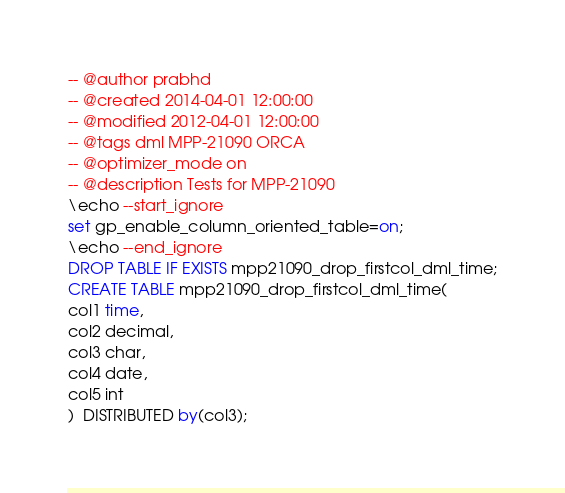<code> <loc_0><loc_0><loc_500><loc_500><_SQL_>-- @author prabhd 
-- @created 2014-04-01 12:00:00
-- @modified 2012-04-01 12:00:00
-- @tags dml MPP-21090 ORCA
-- @optimizer_mode on	
-- @description Tests for MPP-21090
\echo --start_ignore
set gp_enable_column_oriented_table=on;
\echo --end_ignore
DROP TABLE IF EXISTS mpp21090_drop_firstcol_dml_time;
CREATE TABLE mpp21090_drop_firstcol_dml_time(
col1 time,
col2 decimal,
col3 char,
col4 date,
col5 int
)  DISTRIBUTED by(col3);</code> 